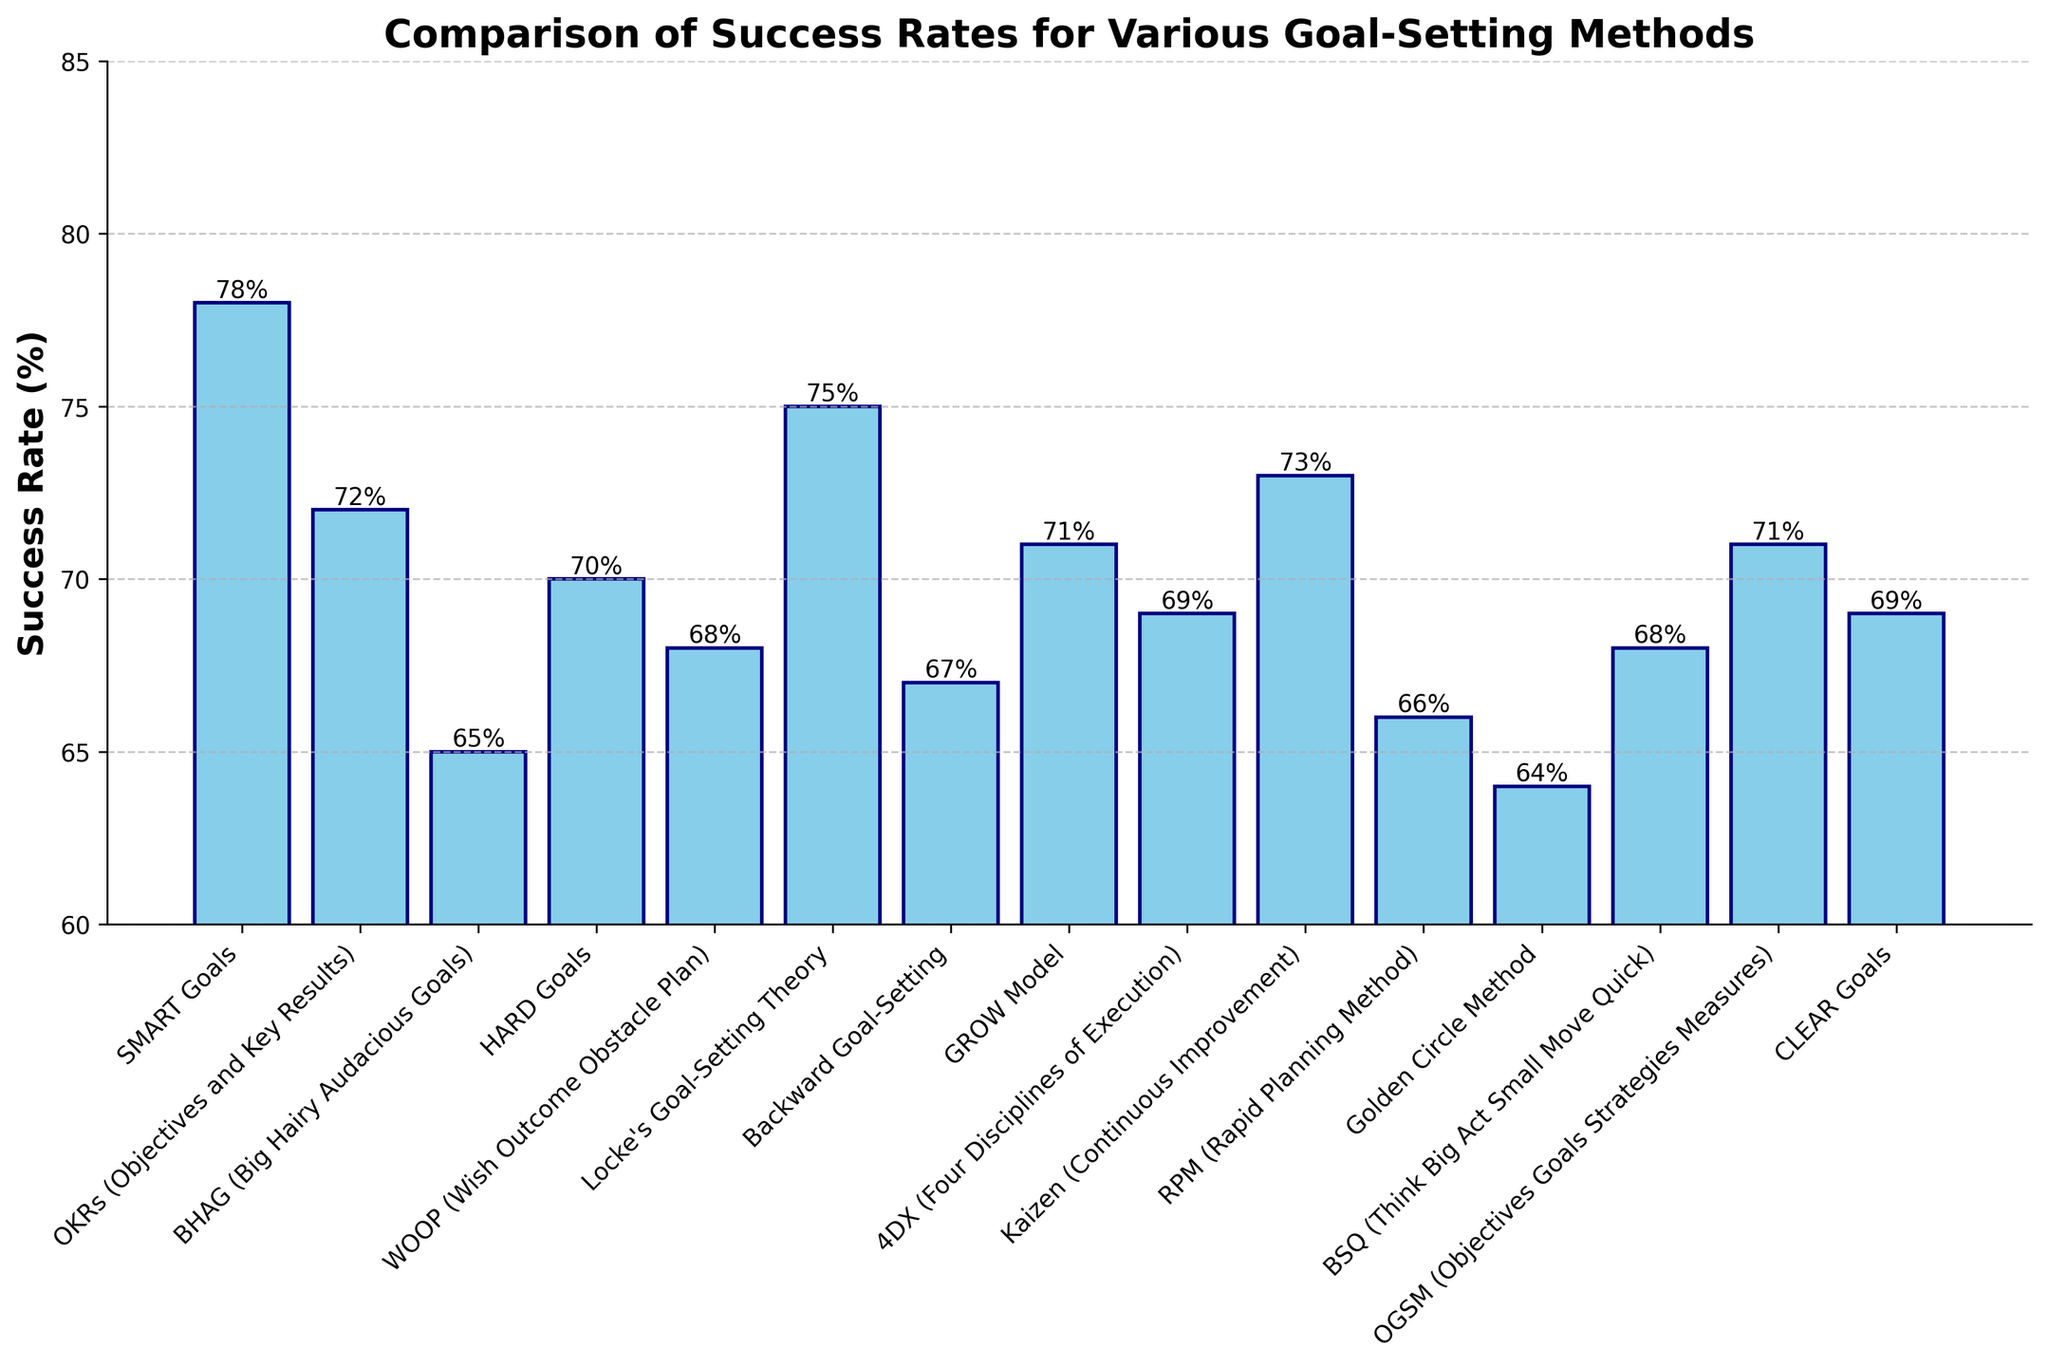What is the success rate of SMART Goals? The bar representing SMART Goals has a height labeled with the success rate of 78%.
Answer: 78% Which goal-setting method has the highest success rate? By visually comparing the heights of the bars, SMART Goals has the tallest bar with a success rate of 78%.
Answer: SMART Goals What is the difference in success rate between SMART Goals and Golden Circle Method? Subtract the success rate of Golden Circle Method (64%) from SMART Goals (78%). 78% - 64% = 14%
Answer: 14% What are the methods with success rates above 70%? Checking the heights of the bars, the methods with success rates above 70% are SMART Goals (78%), OKRs (72%), Locke's Goal-Setting Theory (75%), Kaizen (73%), and GROW Model (71%).
Answer: SMART Goals, OKRs, Locke's Goal-Setting Theory, Kaizen, GROW Model What is the average success rate of all the goal-setting methods? Sum all the success rates (78 + 72 + 65 + 70 + 68 + 75 + 67 + 71 + 69 + 73 + 66 + 64 + 68 + 71 + 69) then divide by the number of methods (15). Total sum is 1086. 1086 / 15 = 72.4%
Answer: 72.4% Which method has the lowest success rate? By comparing the shortest bar, the Golden Circle Method has the lowest success rate at 64%.
Answer: Golden Circle Method Is the success rate of OKRs higher than the success rate of HARD Goals? Compare the heights of the bars for OKRs (72%) and HARD Goals (70%). Since 72% is greater than 70%, YES.
Answer: Yes What is the combined success rate of the top 3 goal-setting methods? Identify the top 3 methods: SMART Goals (78%), Locke's Goal-Setting Theory (75%), and Kaizen (73%). Sum the success rates: 78 + 75 + 73 = 226%
Answer: 226% How many goal-setting methods have a success rate between 65% and 70% inclusive? Count the methods with success rates in this range (BHAG 65%, HARD Goals 70%, WOOP 68%, Backward Goal-Setting 67%, 4DX 69%, RPM 66%, BSQ 68%, CLEAR Goals 69%). Total is 8
Answer: 8 Is the success rate of WOOP closer to that of Backward Goal-Setting or GROW Model? Compare the success rates: WOOP (68%), Backward Goal-Setting (67%), and GROW Model (71%). Difference with Backward Goal-Setting: 1%. Difference with GROW Model: 3%. Therefore, WOOP is closer to Backward Goal-Setting.
Answer: Backward Goal-Setting 